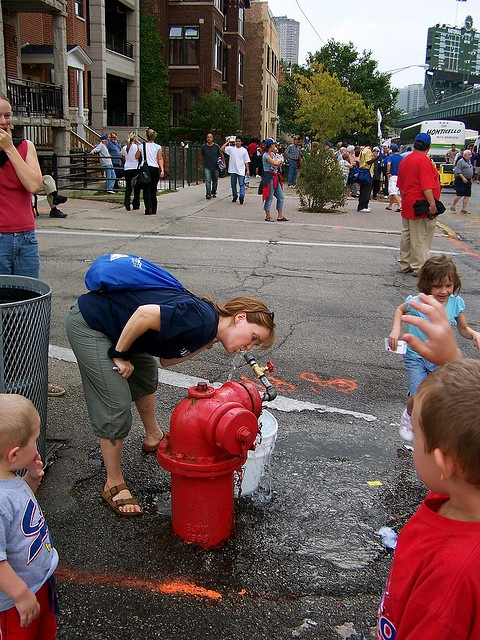Describe the objects in this image and their specific colors. I can see people in gray, brown, and maroon tones, people in gray, black, brown, and maroon tones, fire hydrant in gray, maroon, salmon, and black tones, people in gray, brown, maroon, and black tones, and people in gray, black, darkgray, and navy tones in this image. 